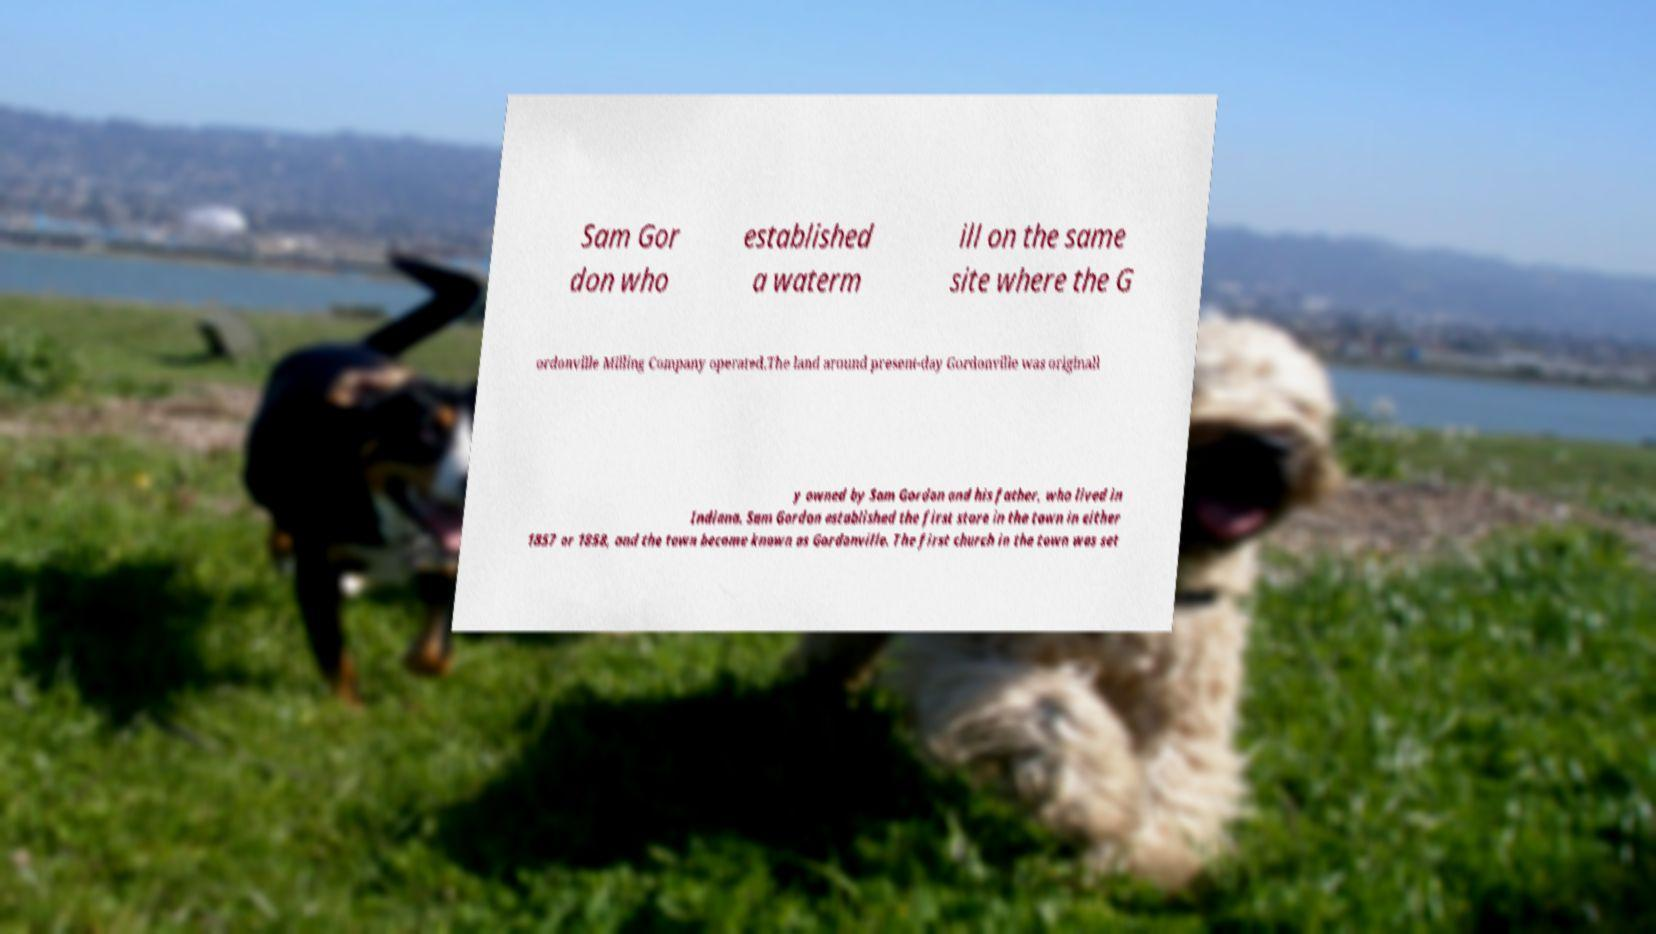Can you read and provide the text displayed in the image?This photo seems to have some interesting text. Can you extract and type it out for me? Sam Gor don who established a waterm ill on the same site where the G ordonville Milling Company operated.The land around present-day Gordonville was originall y owned by Sam Gordon and his father, who lived in Indiana. Sam Gordon established the first store in the town in either 1857 or 1858, and the town became known as Gordonville. The first church in the town was set 